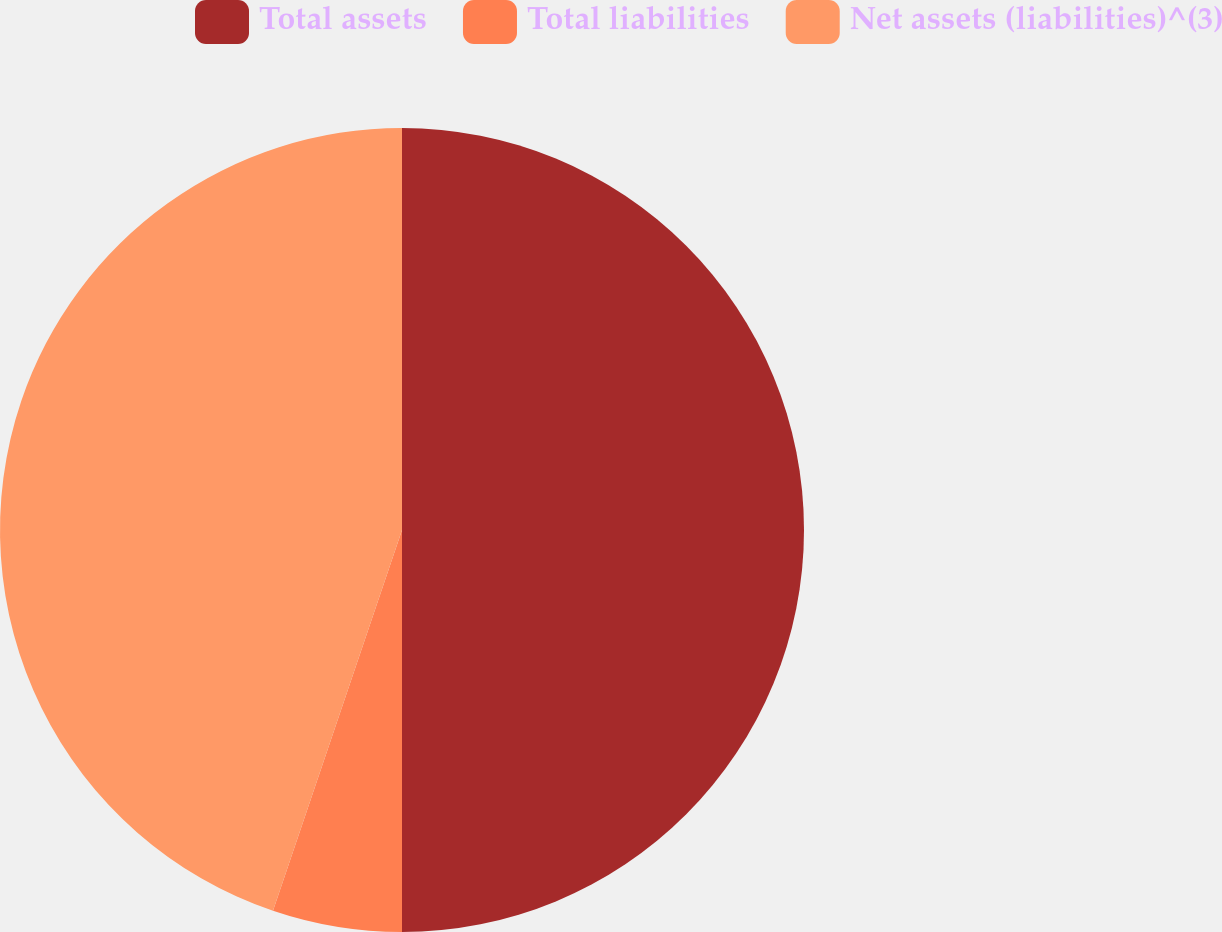Convert chart. <chart><loc_0><loc_0><loc_500><loc_500><pie_chart><fcel>Total assets<fcel>Total liabilities<fcel>Net assets (liabilities)^(3)<nl><fcel>50.0%<fcel>5.2%<fcel>44.8%<nl></chart> 